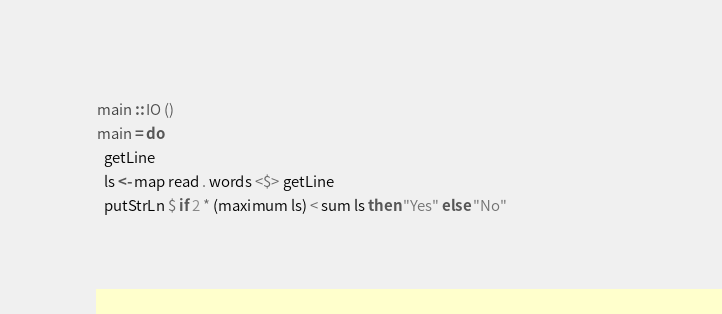<code> <loc_0><loc_0><loc_500><loc_500><_Haskell_>main :: IO ()                                                                                                              
main = do                                                                                                                  
  getLine                                                                                                                  
  ls <- map read . words <$> getLine                                                                                       
  putStrLn $ if 2 * (maximum ls) < sum ls then "Yes" else "No"</code> 